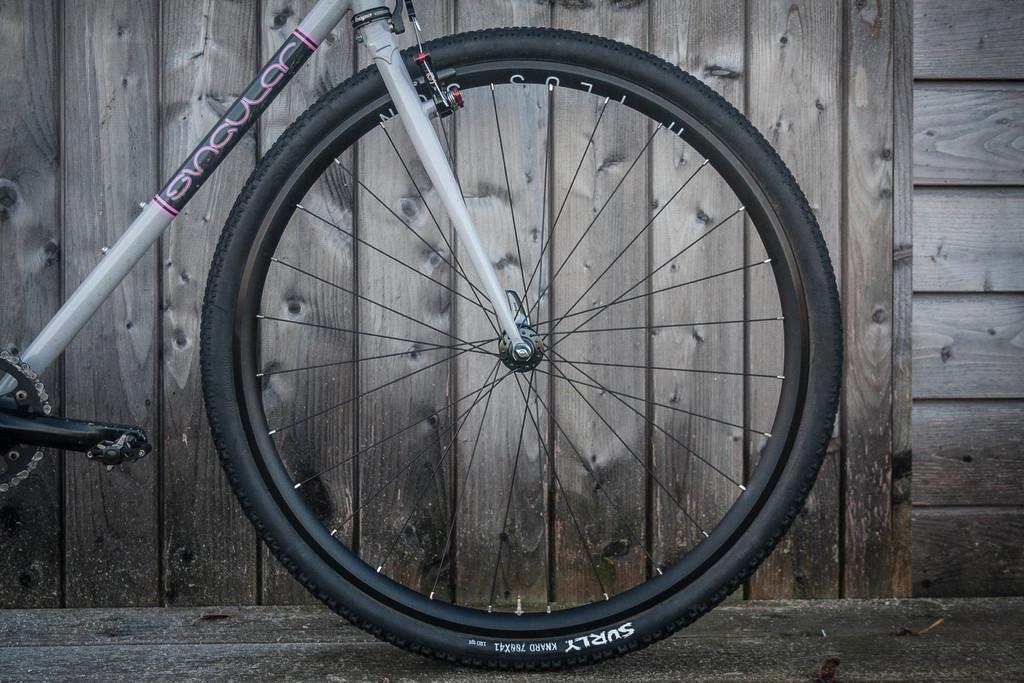Can you describe this image briefly? In this image I can see a bicycle which is white and black in color is on the ground. In the background I can see the wooden wall. 